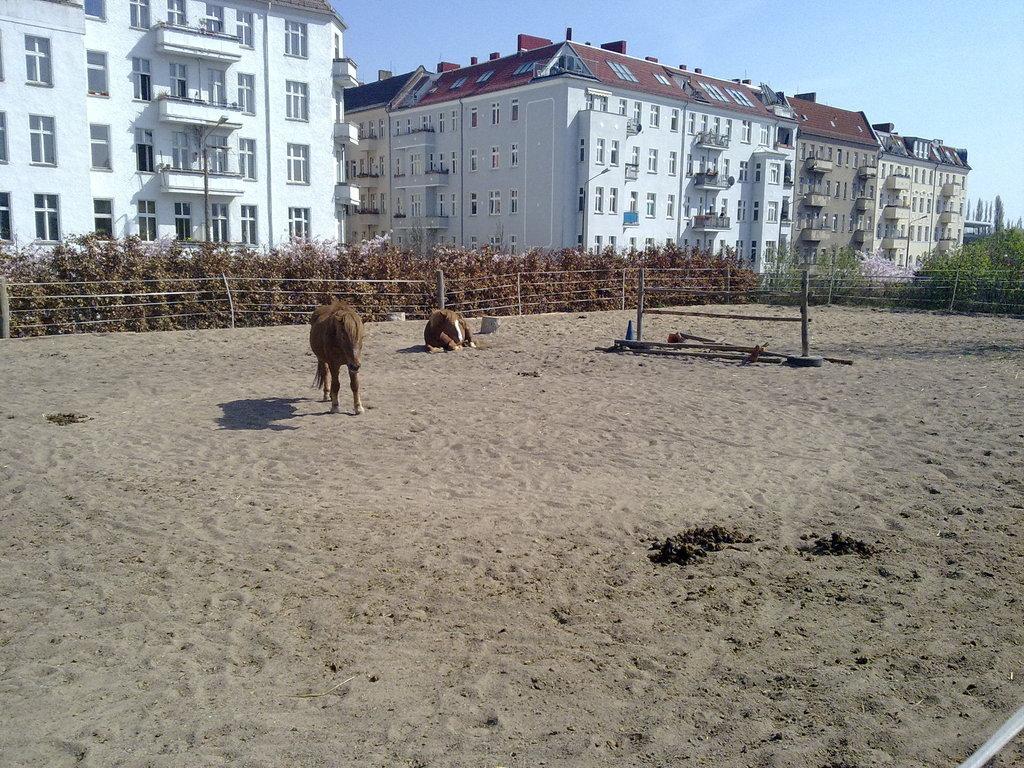In one or two sentences, can you explain what this image depicts? In this image in the front there is sand on the ground and there are animals in the center. In the background there are plants, buildings and on the right side there are trees. 